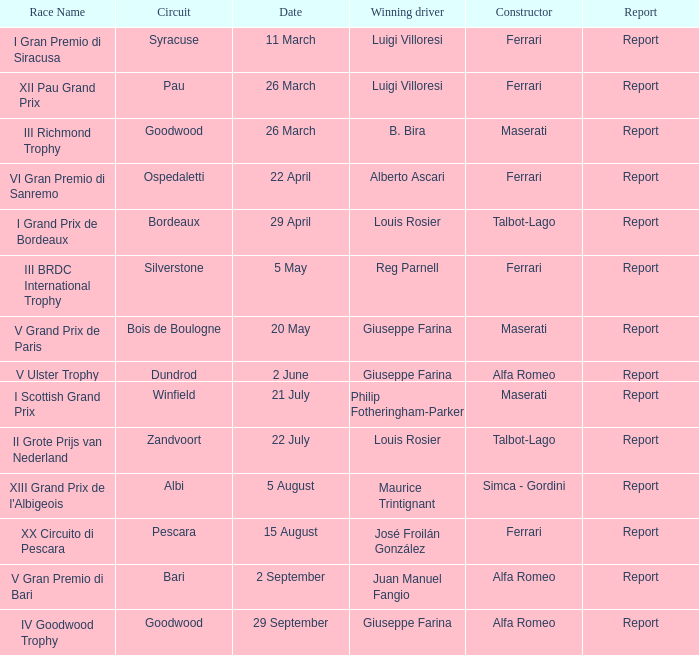Name the report for v grand prix de paris Report. 